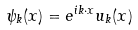Convert formula to latex. <formula><loc_0><loc_0><loc_500><loc_500>\psi _ { k } ( x ) = e ^ { i k \cdot x } u _ { k } ( x )</formula> 